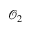<formula> <loc_0><loc_0><loc_500><loc_500>\mathcal { O } _ { 2 }</formula> 